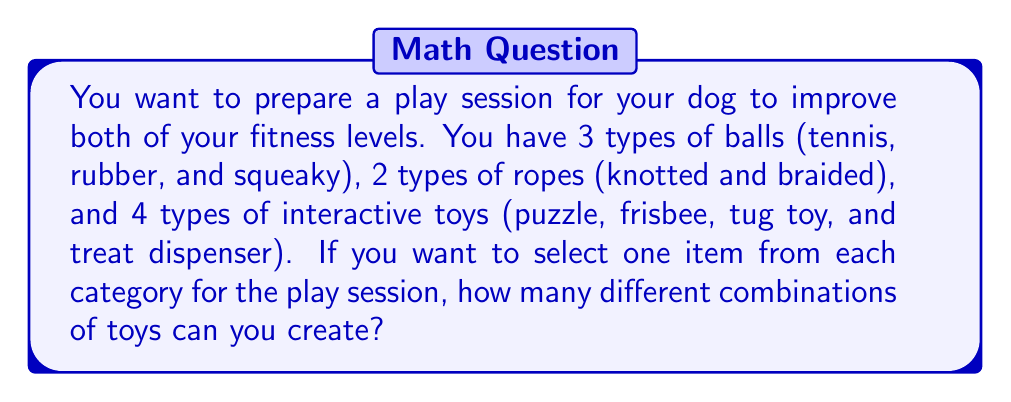Give your solution to this math problem. Let's approach this step-by-step using the multiplication principle of counting:

1) We need to choose one item from each of the three categories:
   - Balls
   - Ropes
   - Interactive toys

2) For each category, we have:
   - 3 choices for balls
   - 2 choices for ropes
   - 4 choices for interactive toys

3) According to the multiplication principle, when we need to make multiple independent choices, we multiply the number of ways to make each choice:

   $$\text{Total combinations} = \text{Ball choices} \times \text{Rope choices} \times \text{Interactive toy choices}$$

4) Substituting the numbers:

   $$\text{Total combinations} = 3 \times 2 \times 4$$

5) Calculating:

   $$\text{Total combinations} = 24$$

Therefore, you can create 24 different combinations of toys for your play session.
Answer: 24 